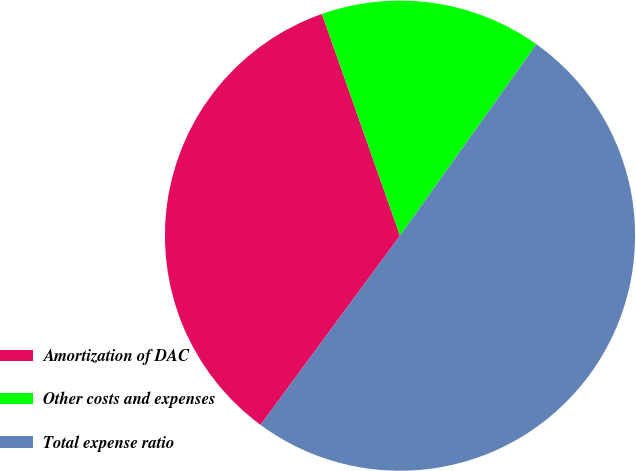Convert chart to OTSL. <chart><loc_0><loc_0><loc_500><loc_500><pie_chart><fcel>Amortization of DAC<fcel>Other costs and expenses<fcel>Total expense ratio<nl><fcel>34.5%<fcel>15.24%<fcel>50.26%<nl></chart> 